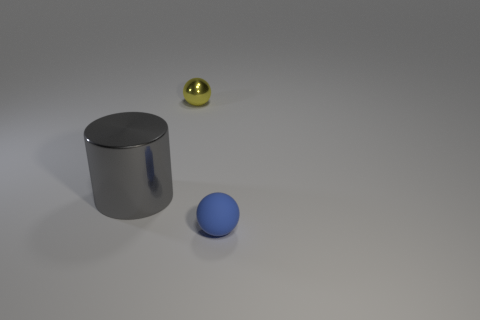Add 3 small yellow metallic objects. How many objects exist? 6 Subtract all balls. How many objects are left? 1 Subtract 0 red cylinders. How many objects are left? 3 Subtract all big metallic cylinders. Subtract all tiny matte balls. How many objects are left? 1 Add 3 yellow spheres. How many yellow spheres are left? 4 Add 1 blue spheres. How many blue spheres exist? 2 